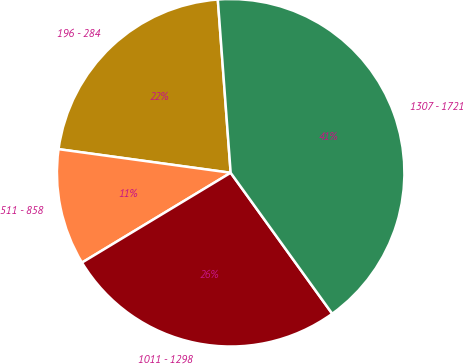Convert chart. <chart><loc_0><loc_0><loc_500><loc_500><pie_chart><fcel>196 - 284<fcel>511 - 858<fcel>1011 - 1298<fcel>1307 - 1721<nl><fcel>21.65%<fcel>10.82%<fcel>26.29%<fcel>41.24%<nl></chart> 